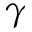<formula> <loc_0><loc_0><loc_500><loc_500>\gamma</formula> 